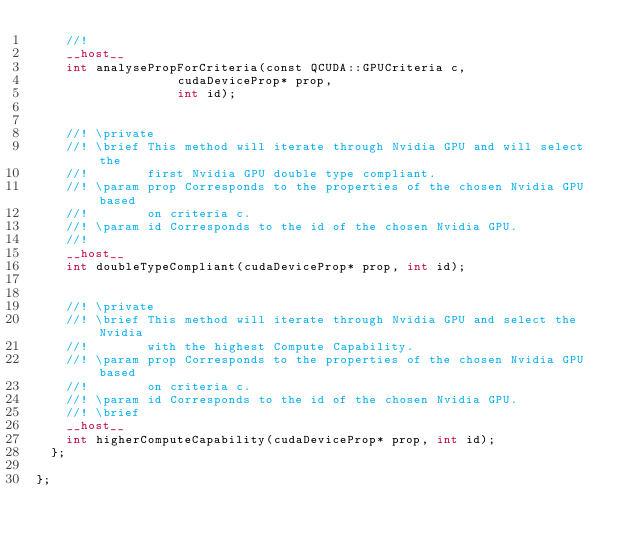Convert code to text. <code><loc_0><loc_0><loc_500><loc_500><_Cuda_>    //!
    __host__
    int	analysePropForCriteria(const QCUDA::GPUCriteria c,
			       cudaDeviceProp* prop,
			       int id);


    //! \private
    //! \brief This method will iterate through Nvidia GPU and will select the
    //!        first Nvidia GPU double type compliant.
    //! \param prop Corresponds to the properties of the chosen Nvidia GPU based
    //!        on criteria c.
    //! \param id Corresponds to the id of the chosen Nvidia GPU.
    //! 
    __host__
    int	doubleTypeCompliant(cudaDeviceProp* prop, int id);

    
    //! \private
    //! \brief This method will iterate through Nvidia GPU and select the Nvidia
    //!        with the highest Compute Capability.
    //! \param prop Corresponds to the properties of the chosen Nvidia GPU based
    //!        on criteria c.
    //! \param id Corresponds to the id of the chosen Nvidia GPU.
    //! \brief 
    __host__
    int	higherComputeCapability(cudaDeviceProp* prop, int id);
  };

};
</code> 